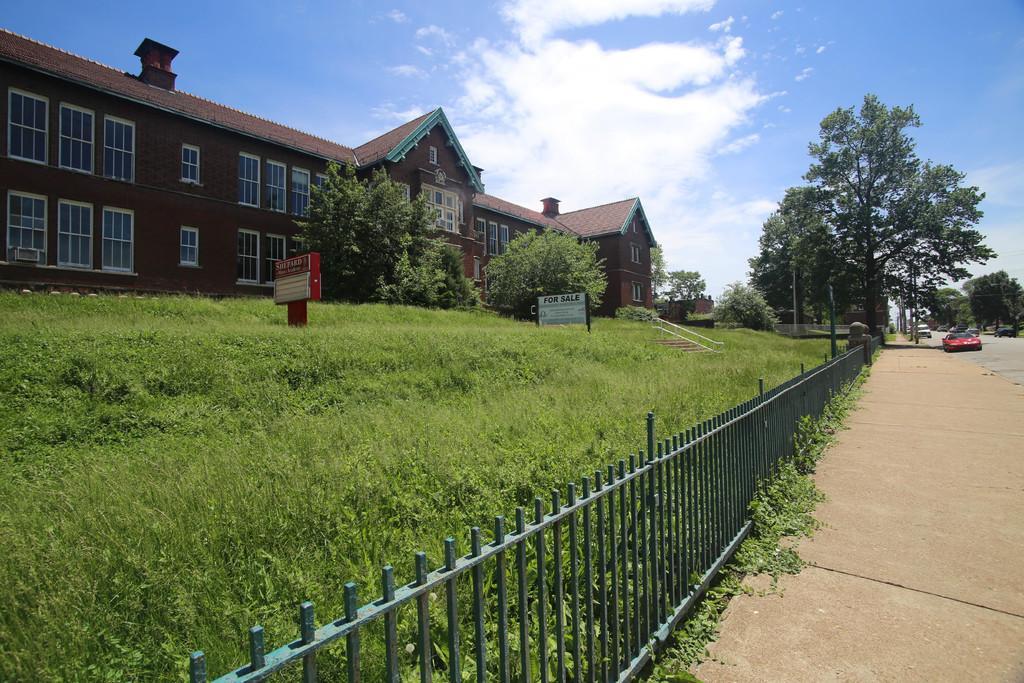How would you summarize this image in a sentence or two? In this image, we can see building, walls, windows, trees, plants, boards, railings, poles, vehicles, walkway and road. Background there is the sky. 